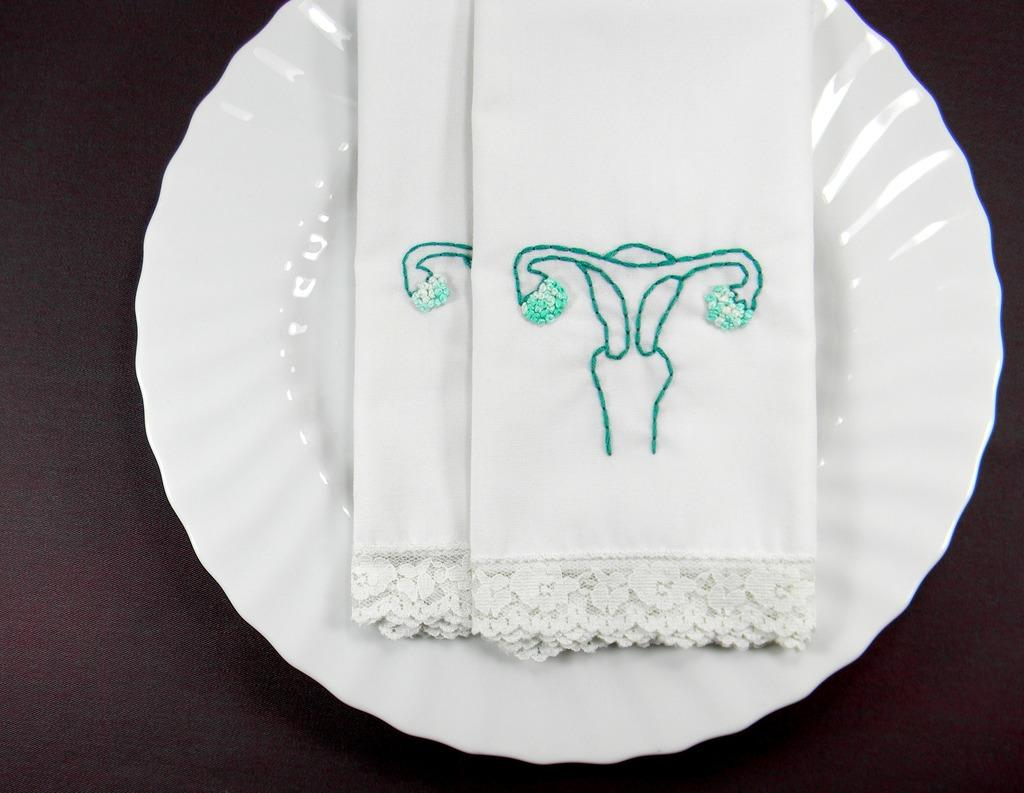What object is present on the plate in the image? There is a plate in the image, and on it, there are two white clothes. What is on the white clothes? There is an image stretched on the white clothes. What grade is the calendar on the plate? There is no calendar present in the image, so the concept of a grade does not apply. 